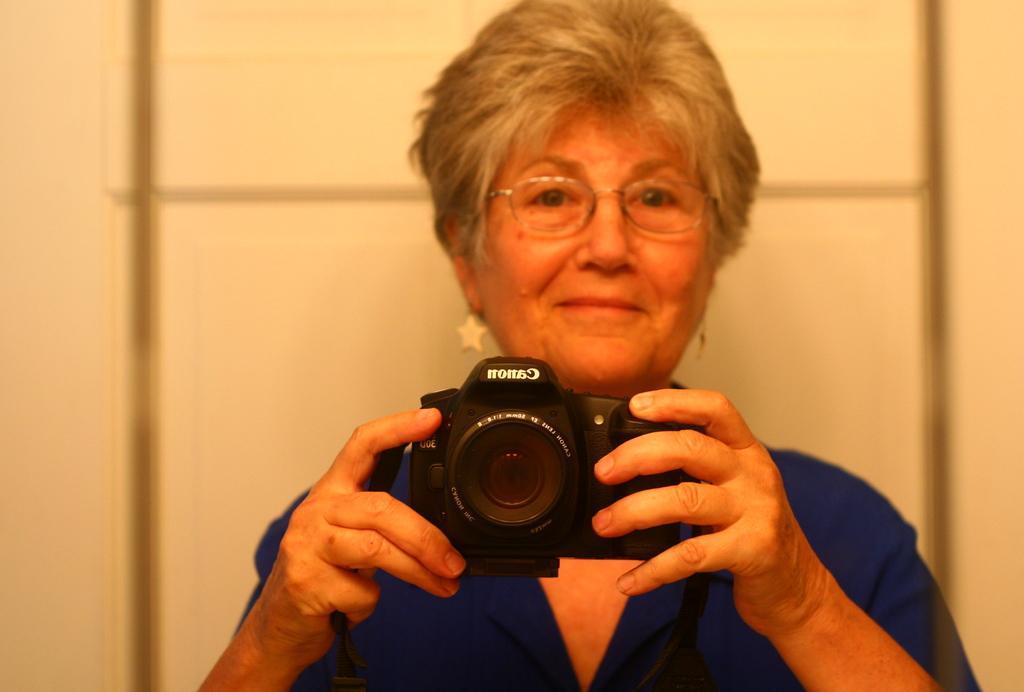Can you describe this image briefly? In the picture I can see a woman wearing blue dress is holding a camera and the background is in white color. 